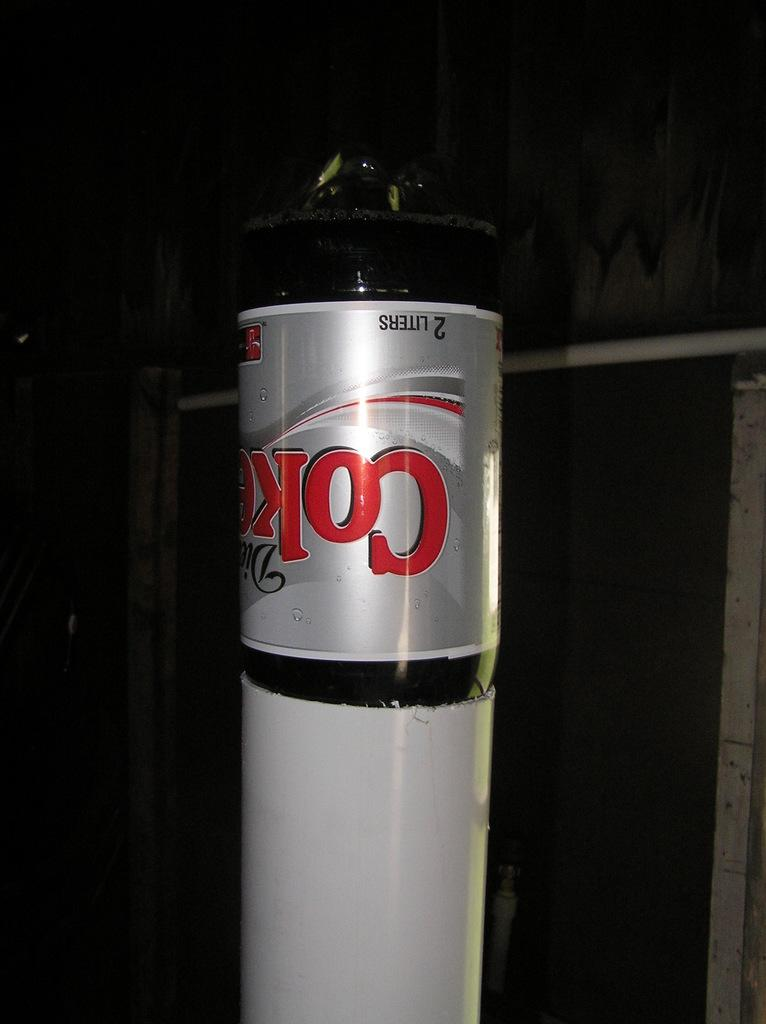<image>
Offer a succinct explanation of the picture presented. Coke bottle upside down and says 2 liters on it. 